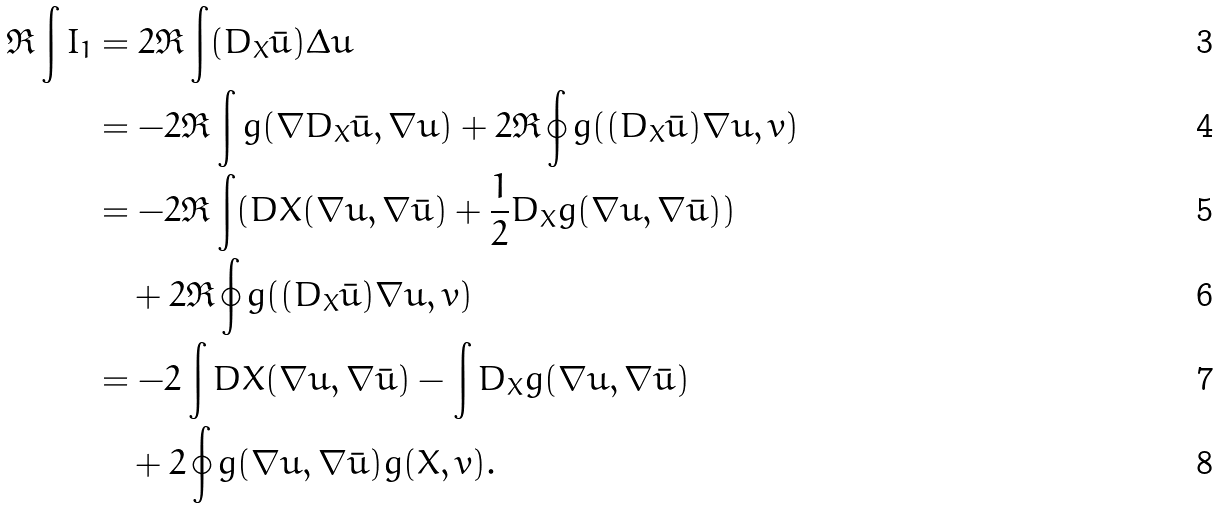<formula> <loc_0><loc_0><loc_500><loc_500>\Re \int I _ { 1 } & = 2 \Re \int ( D _ { X } \bar { u } ) \Delta u \\ & = - 2 \Re \int g ( \nabla D _ { X } \bar { u } , \nabla u ) + 2 \Re \oint g ( ( D _ { X } \bar { u } ) \nabla u , { v } ) \\ & = - 2 \Re \int ( D { X } ( \nabla u , \nabla \bar { u } ) + \frac { 1 } { 2 } D _ { X } g ( \nabla u , \nabla \bar { u } ) ) \\ & \quad + 2 \Re \oint g ( ( D _ { X } \bar { u } ) \nabla u , { v } ) \\ & = - 2 \int D { X } ( \nabla u , \nabla \bar { u } ) - \int D _ { X } g ( \nabla u , \nabla \bar { u } ) \\ & \quad + 2 \oint g ( \nabla u , \nabla \bar { u } ) g ( { X } , { v } ) .</formula> 